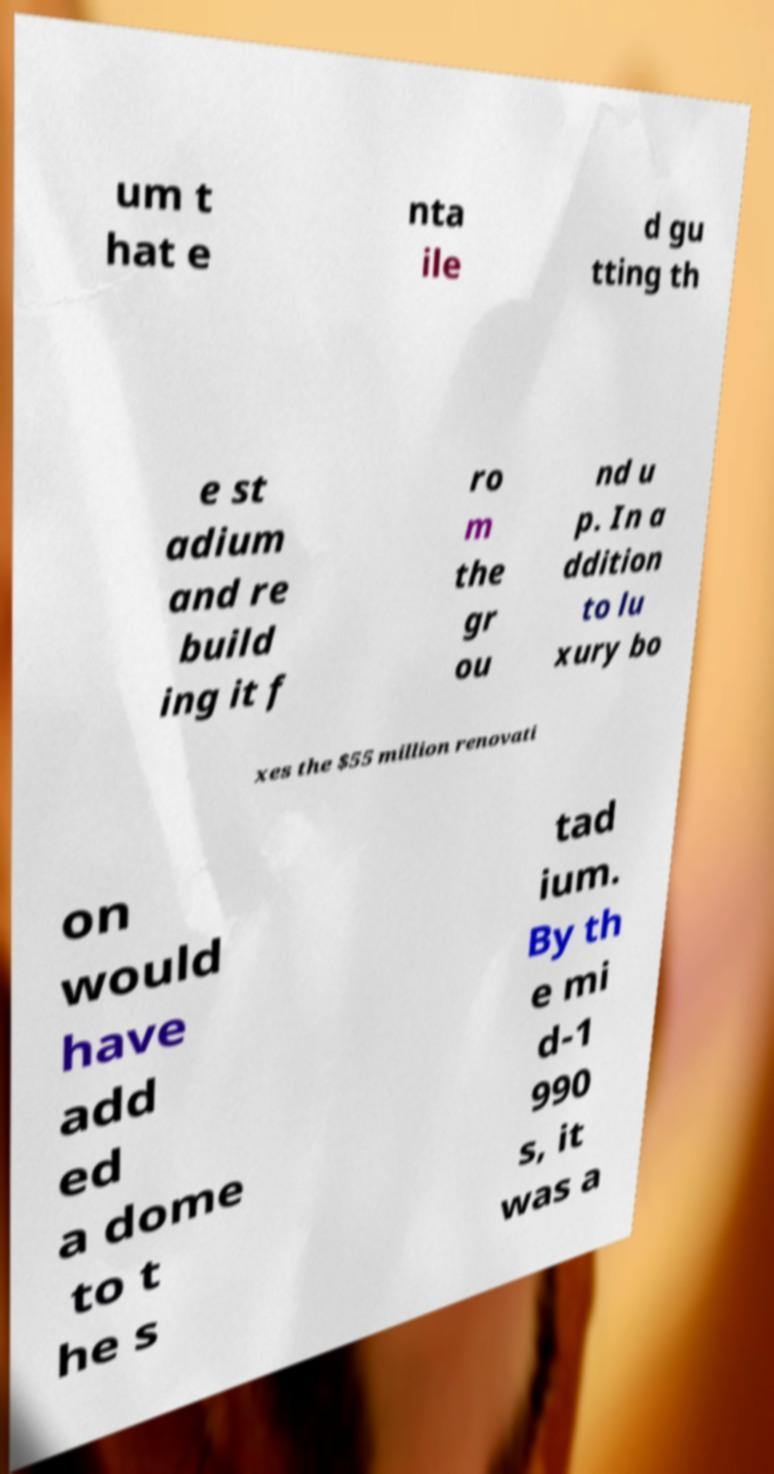Could you assist in decoding the text presented in this image and type it out clearly? um t hat e nta ile d gu tting th e st adium and re build ing it f ro m the gr ou nd u p. In a ddition to lu xury bo xes the $55 million renovati on would have add ed a dome to t he s tad ium. By th e mi d-1 990 s, it was a 